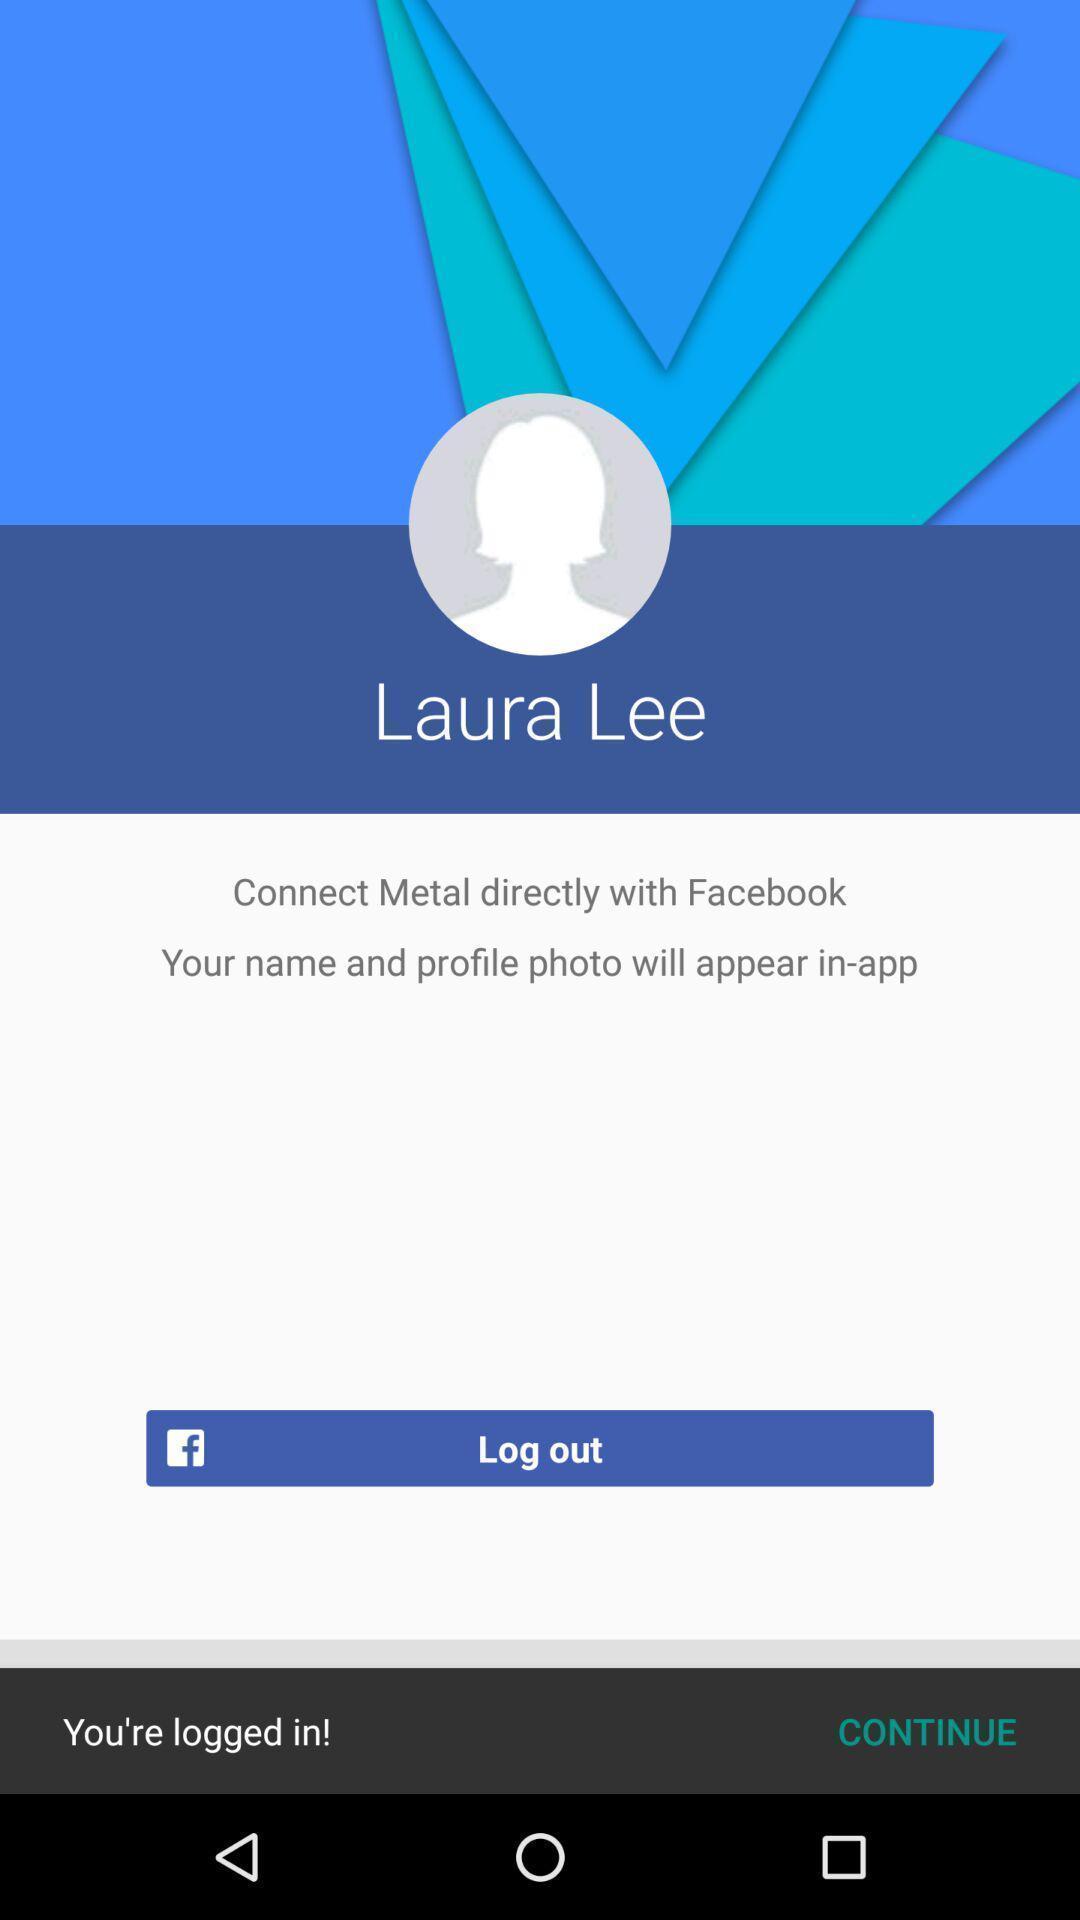Provide a detailed account of this screenshot. Screen showing log out page. 